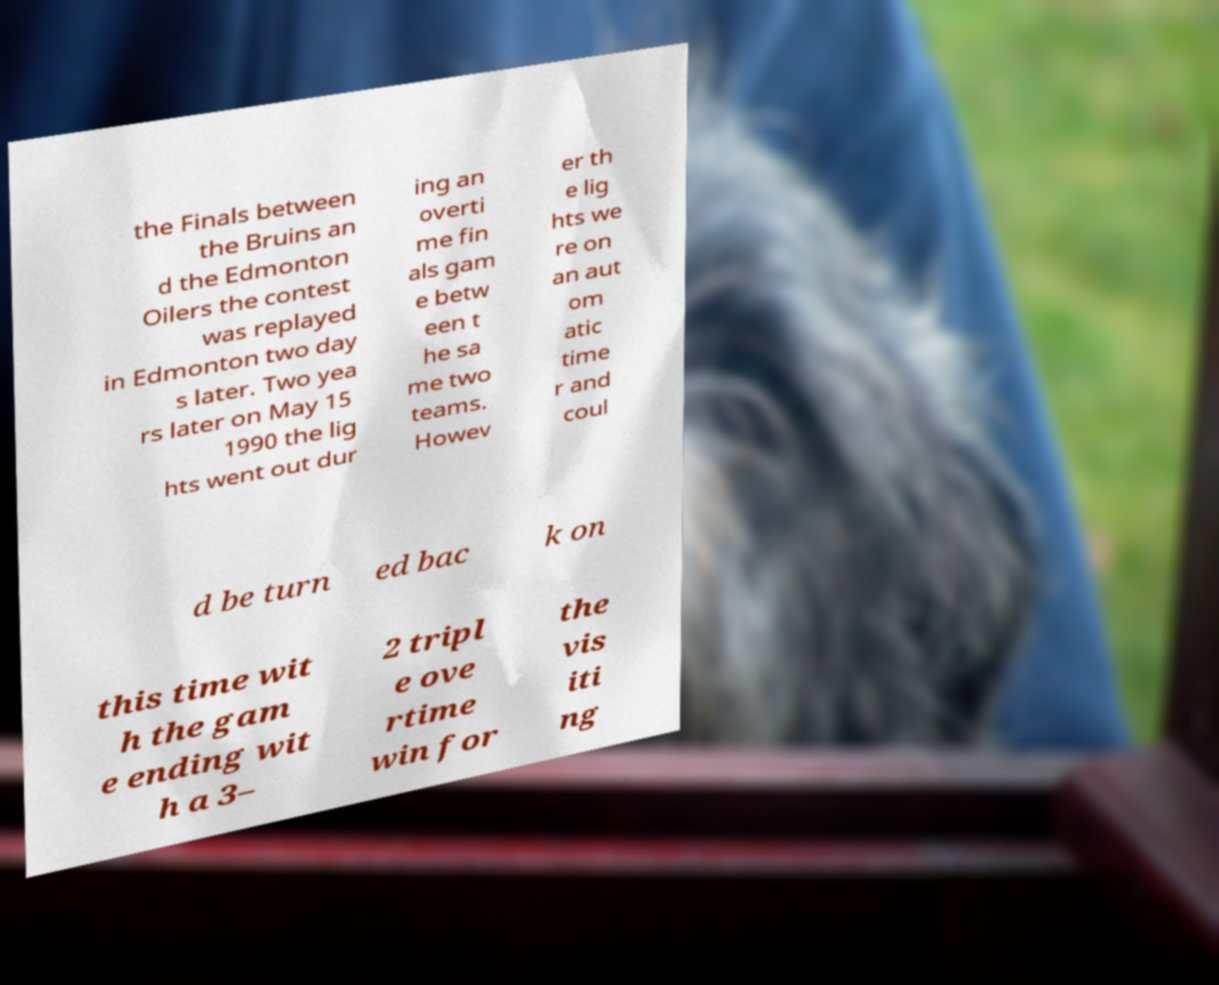There's text embedded in this image that I need extracted. Can you transcribe it verbatim? the Finals between the Bruins an d the Edmonton Oilers the contest was replayed in Edmonton two day s later. Two yea rs later on May 15 1990 the lig hts went out dur ing an overti me fin als gam e betw een t he sa me two teams. Howev er th e lig hts we re on an aut om atic time r and coul d be turn ed bac k on this time wit h the gam e ending wit h a 3– 2 tripl e ove rtime win for the vis iti ng 